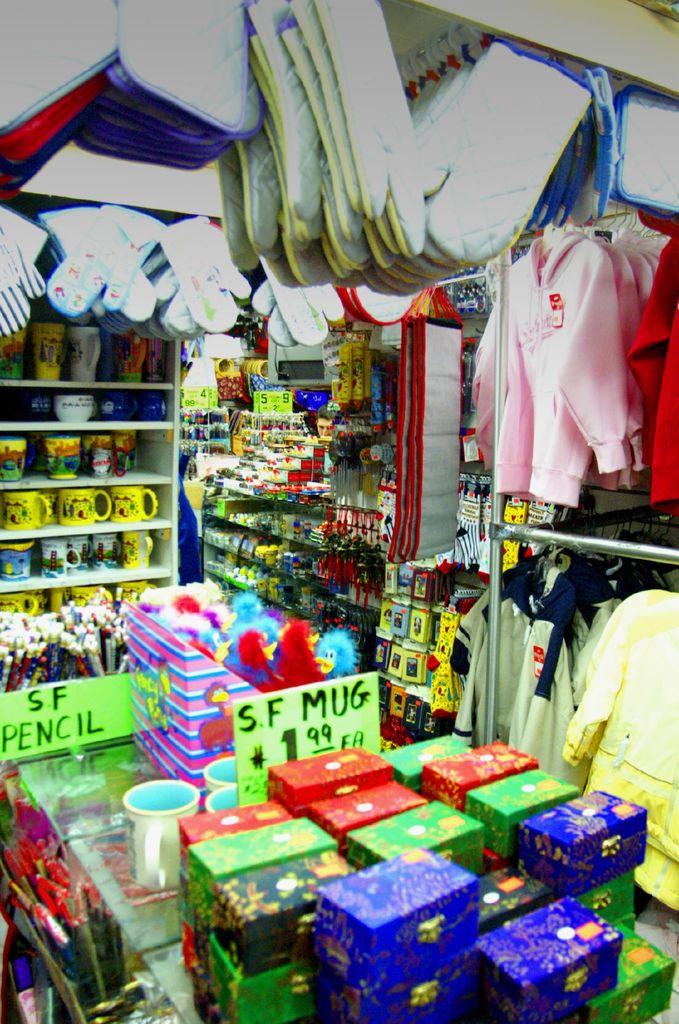What are the pencils called?
Your answer should be compact. Sf pencil. How much if the s f mug?
Offer a very short reply. 1.99. 